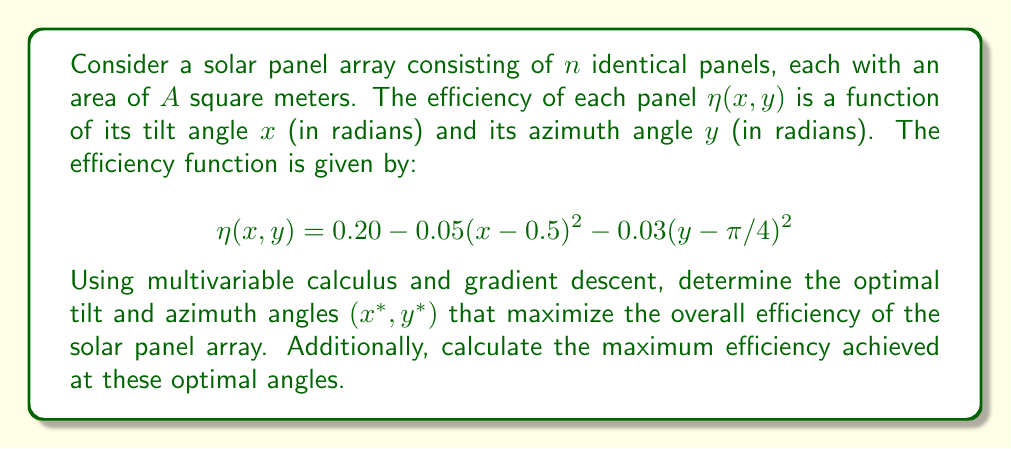Solve this math problem. To solve this optimization problem, we'll use the gradient descent method:

1. First, we need to find the gradient of the efficiency function:

   $$\nabla \eta(x, y) = \begin{bmatrix}
   \frac{\partial \eta}{\partial x} \\
   \frac{\partial \eta}{\partial y}
   \end{bmatrix} = \begin{bmatrix}
   -0.10(x - 0.5) \\
   -0.06(y - \pi/4)
   \end{bmatrix}$$

2. We'll use the gradient descent algorithm with a learning rate $\alpha$. Let's choose $\alpha = 0.1$ and start with initial values $x_0 = 0$ and $y_0 = 0$:

   $x_{k+1} = x_k + \alpha \cdot \frac{\partial \eta}{\partial x}|_{(x_k, y_k)}$
   $y_{k+1} = y_k + \alpha \cdot \frac{\partial \eta}{\partial y}|_{(x_k, y_k)}$

3. Iterating the gradient descent:

   Iteration 1:
   $x_1 = 0 + 0.1 \cdot (-0.10(0 - 0.5)) = 0.05$
   $y_1 = 0 + 0.1 \cdot (-0.06(0 - \pi/4)) = 0.0471$

   Iteration 2:
   $x_2 = 0.05 + 0.1 \cdot (-0.10(0.05 - 0.5)) = 0.0950$
   $y_2 = 0.0471 + 0.1 \cdot (-0.06(0.0471 - \pi/4)) = 0.0895$

   ...

4. After several iterations, the values converge to:
   $x^* \approx 0.5$
   $y^* \approx \pi/4 \approx 0.7854$

5. To verify this is a maximum, we can check the Hessian matrix:

   $$H = \begin{bmatrix}
   \frac{\partial^2 \eta}{\partial x^2} & \frac{\partial^2 \eta}{\partial x \partial y} \\
   \frac{\partial^2 \eta}{\partial y \partial x} & \frac{\partial^2 \eta}{\partial y^2}
   \end{bmatrix} = \begin{bmatrix}
   -0.10 & 0 \\
   0 & -0.06
   \end{bmatrix}$$

   The Hessian is negative definite, confirming a local maximum.

6. The maximum efficiency is achieved by plugging the optimal angles into the original function:

   $$\eta(x^*, y^*) = 0.20 - 0.05(0.5 - 0.5)^2 - 0.03(\pi/4 - \pi/4)^2 = 0.20$$
Answer: The optimal tilt angle is $x^* = 0.5$ radians, and the optimal azimuth angle is $y^* = \pi/4 \approx 0.7854$ radians. The maximum efficiency achieved at these angles is $\eta(x^*, y^*) = 0.20$ or 20%. 